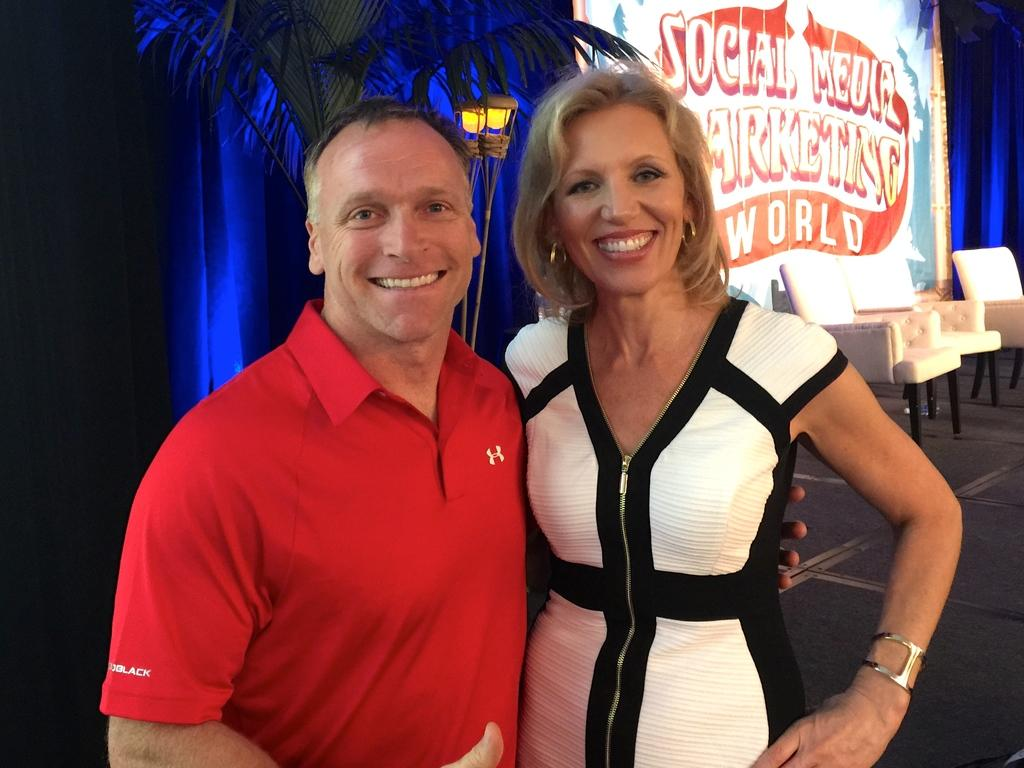<image>
Write a terse but informative summary of the picture. A man in orange smiling standing beside a woman with a white social media sign in back. 